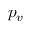Convert formula to latex. <formula><loc_0><loc_0><loc_500><loc_500>p _ { v }</formula> 